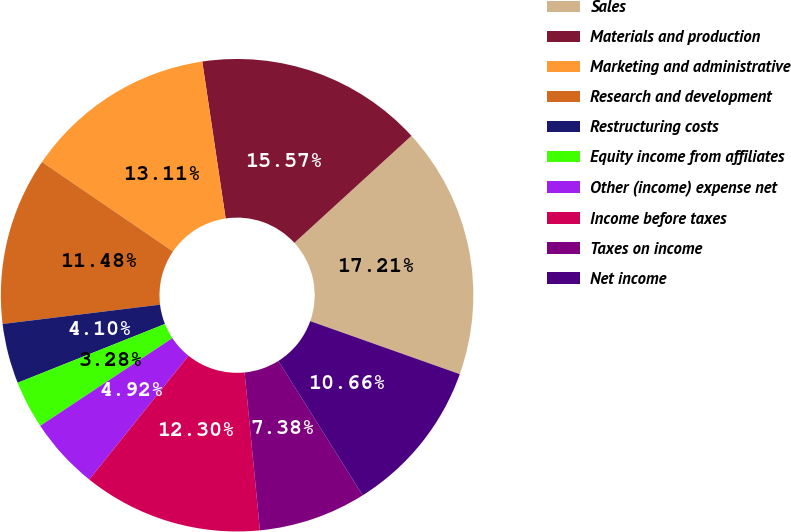Convert chart. <chart><loc_0><loc_0><loc_500><loc_500><pie_chart><fcel>Sales<fcel>Materials and production<fcel>Marketing and administrative<fcel>Research and development<fcel>Restructuring costs<fcel>Equity income from affiliates<fcel>Other (income) expense net<fcel>Income before taxes<fcel>Taxes on income<fcel>Net income<nl><fcel>17.21%<fcel>15.57%<fcel>13.11%<fcel>11.48%<fcel>4.1%<fcel>3.28%<fcel>4.92%<fcel>12.3%<fcel>7.38%<fcel>10.66%<nl></chart> 